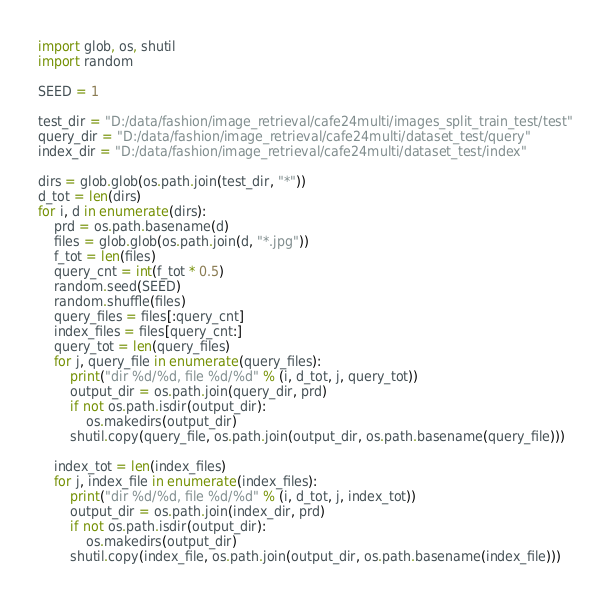<code> <loc_0><loc_0><loc_500><loc_500><_Python_>import glob, os, shutil
import random

SEED = 1

test_dir = "D:/data/fashion/image_retrieval/cafe24multi/images_split_train_test/test"
query_dir = "D:/data/fashion/image_retrieval/cafe24multi/dataset_test/query"
index_dir = "D:/data/fashion/image_retrieval/cafe24multi/dataset_test/index"

dirs = glob.glob(os.path.join(test_dir, "*"))
d_tot = len(dirs)
for i, d in enumerate(dirs):
    prd = os.path.basename(d)
    files = glob.glob(os.path.join(d, "*.jpg"))
    f_tot = len(files)
    query_cnt = int(f_tot * 0.5)
    random.seed(SEED)
    random.shuffle(files)
    query_files = files[:query_cnt]
    index_files = files[query_cnt:]
    query_tot = len(query_files)
    for j, query_file in enumerate(query_files):
        print("dir %d/%d, file %d/%d" % (i, d_tot, j, query_tot))
        output_dir = os.path.join(query_dir, prd)
        if not os.path.isdir(output_dir):
            os.makedirs(output_dir)
        shutil.copy(query_file, os.path.join(output_dir, os.path.basename(query_file)))

    index_tot = len(index_files)
    for j, index_file in enumerate(index_files):
        print("dir %d/%d, file %d/%d" % (i, d_tot, j, index_tot))
        output_dir = os.path.join(index_dir, prd)
        if not os.path.isdir(output_dir):
            os.makedirs(output_dir)
        shutil.copy(index_file, os.path.join(output_dir, os.path.basename(index_file)))
</code> 